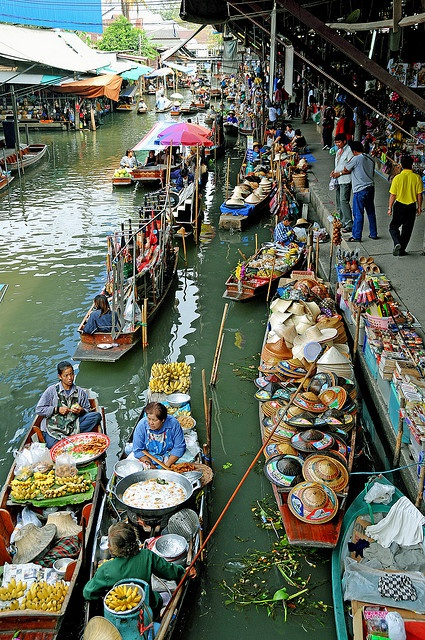Describe the objects in this image and their specific colors. I can see boat in lightblue, black, white, gray, and teal tones, boat in lightblue, black, ivory, tan, and darkgray tones, boat in lightblue, black, lightgray, darkgray, and maroon tones, boat in lightblue, darkgray, gray, lightgray, and black tones, and boat in lightblue, black, gray, darkgray, and lightgray tones in this image. 